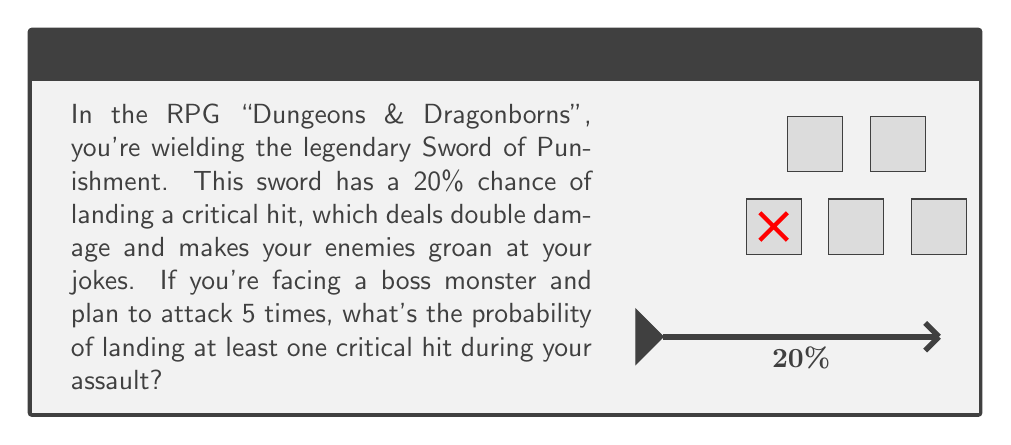Help me with this question. Let's approach this step-by-step:

1) First, let's define our events:
   - Let $C$ be the event of landing a critical hit on a single attack
   - Let $A$ be the event of landing at least one critical hit in 5 attacks

2) We're given that $P(C) = 20\% = 0.2$

3) It's easier to calculate the probability of not landing any critical hits and then subtract from 1:
   $P(A) = 1 - P(\text{no critical hits in 5 attacks})$

4) The probability of not landing a critical hit on a single attack is:
   $P(\text{not }C) = 1 - P(C) = 1 - 0.2 = 0.8$

5) For no critical hits in 5 attacks, we need this to happen 5 times in a row. Since the attacks are independent, we multiply the probabilities:
   $P(\text{no critical hits in 5 attacks}) = 0.8^5$

6) Now we can calculate $P(A)$:
   $$P(A) = 1 - 0.8^5 = 1 - 0.32768 = 0.67232$$

7) Converting to a percentage:
   $0.67232 \times 100\% = 67.232\%$

Therefore, the probability of landing at least one critical hit in 5 attacks is approximately 67.23%.
Answer: $67.23\%$ 